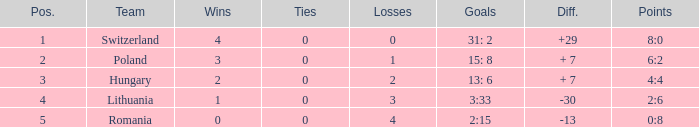What is the most wins when the number of losses was less than 4 and there was more than 0 ties? None. 